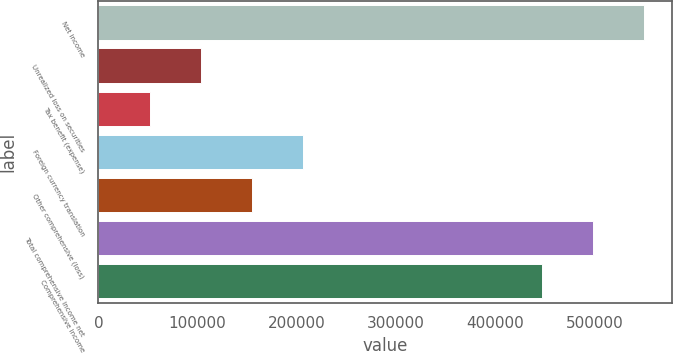<chart> <loc_0><loc_0><loc_500><loc_500><bar_chart><fcel>Net income<fcel>Unrealized loss on securities<fcel>Tax benefit (expense)<fcel>Foreign currency translation<fcel>Other comprehensive (loss)<fcel>Total comprehensive income net<fcel>Comprehensive income<nl><fcel>550323<fcel>103439<fcel>51851.6<fcel>206614<fcel>155027<fcel>498736<fcel>447148<nl></chart> 